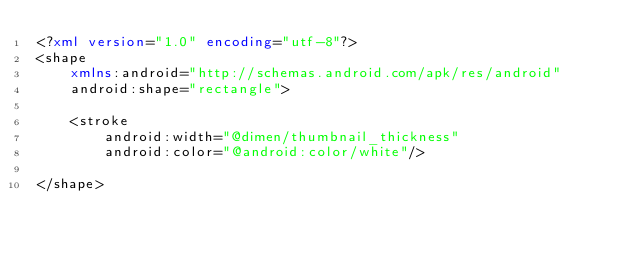Convert code to text. <code><loc_0><loc_0><loc_500><loc_500><_XML_><?xml version="1.0" encoding="utf-8"?>
<shape
    xmlns:android="http://schemas.android.com/apk/res/android"
    android:shape="rectangle">

    <stroke
        android:width="@dimen/thumbnail_thickness"
        android:color="@android:color/white"/>

</shape></code> 